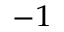<formula> <loc_0><loc_0><loc_500><loc_500>^ { - 1 }</formula> 